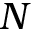Convert formula to latex. <formula><loc_0><loc_0><loc_500><loc_500>N</formula> 